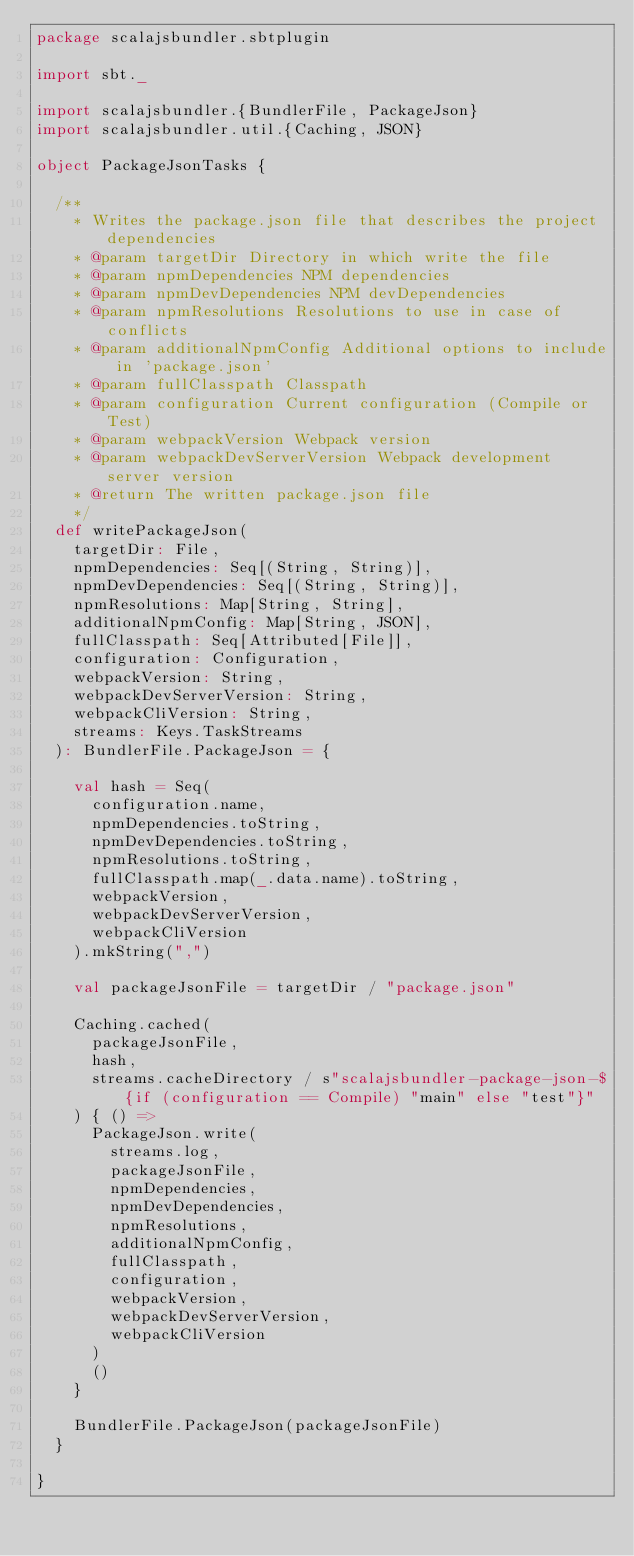Convert code to text. <code><loc_0><loc_0><loc_500><loc_500><_Scala_>package scalajsbundler.sbtplugin

import sbt._

import scalajsbundler.{BundlerFile, PackageJson}
import scalajsbundler.util.{Caching, JSON}

object PackageJsonTasks {

  /**
    * Writes the package.json file that describes the project dependencies
    * @param targetDir Directory in which write the file
    * @param npmDependencies NPM dependencies
    * @param npmDevDependencies NPM devDependencies
    * @param npmResolutions Resolutions to use in case of conflicts
    * @param additionalNpmConfig Additional options to include in 'package.json'
    * @param fullClasspath Classpath
    * @param configuration Current configuration (Compile or Test)
    * @param webpackVersion Webpack version
    * @param webpackDevServerVersion Webpack development server version
    * @return The written package.json file
    */
  def writePackageJson(
    targetDir: File,
    npmDependencies: Seq[(String, String)],
    npmDevDependencies: Seq[(String, String)],
    npmResolutions: Map[String, String],
    additionalNpmConfig: Map[String, JSON],
    fullClasspath: Seq[Attributed[File]],
    configuration: Configuration,
    webpackVersion: String,
    webpackDevServerVersion: String,
    webpackCliVersion: String,
    streams: Keys.TaskStreams
  ): BundlerFile.PackageJson = {

    val hash = Seq(
      configuration.name,
      npmDependencies.toString,
      npmDevDependencies.toString,
      npmResolutions.toString,
      fullClasspath.map(_.data.name).toString,
      webpackVersion,
      webpackDevServerVersion,
      webpackCliVersion
    ).mkString(",")

    val packageJsonFile = targetDir / "package.json"

    Caching.cached(
      packageJsonFile,
      hash,
      streams.cacheDirectory / s"scalajsbundler-package-json-${if (configuration == Compile) "main" else "test"}"
    ) { () =>
      PackageJson.write(
        streams.log,
        packageJsonFile,
        npmDependencies,
        npmDevDependencies,
        npmResolutions,
        additionalNpmConfig,
        fullClasspath,
        configuration,
        webpackVersion,
        webpackDevServerVersion,
        webpackCliVersion
      )
      ()
    }

    BundlerFile.PackageJson(packageJsonFile)
  }

}
</code> 